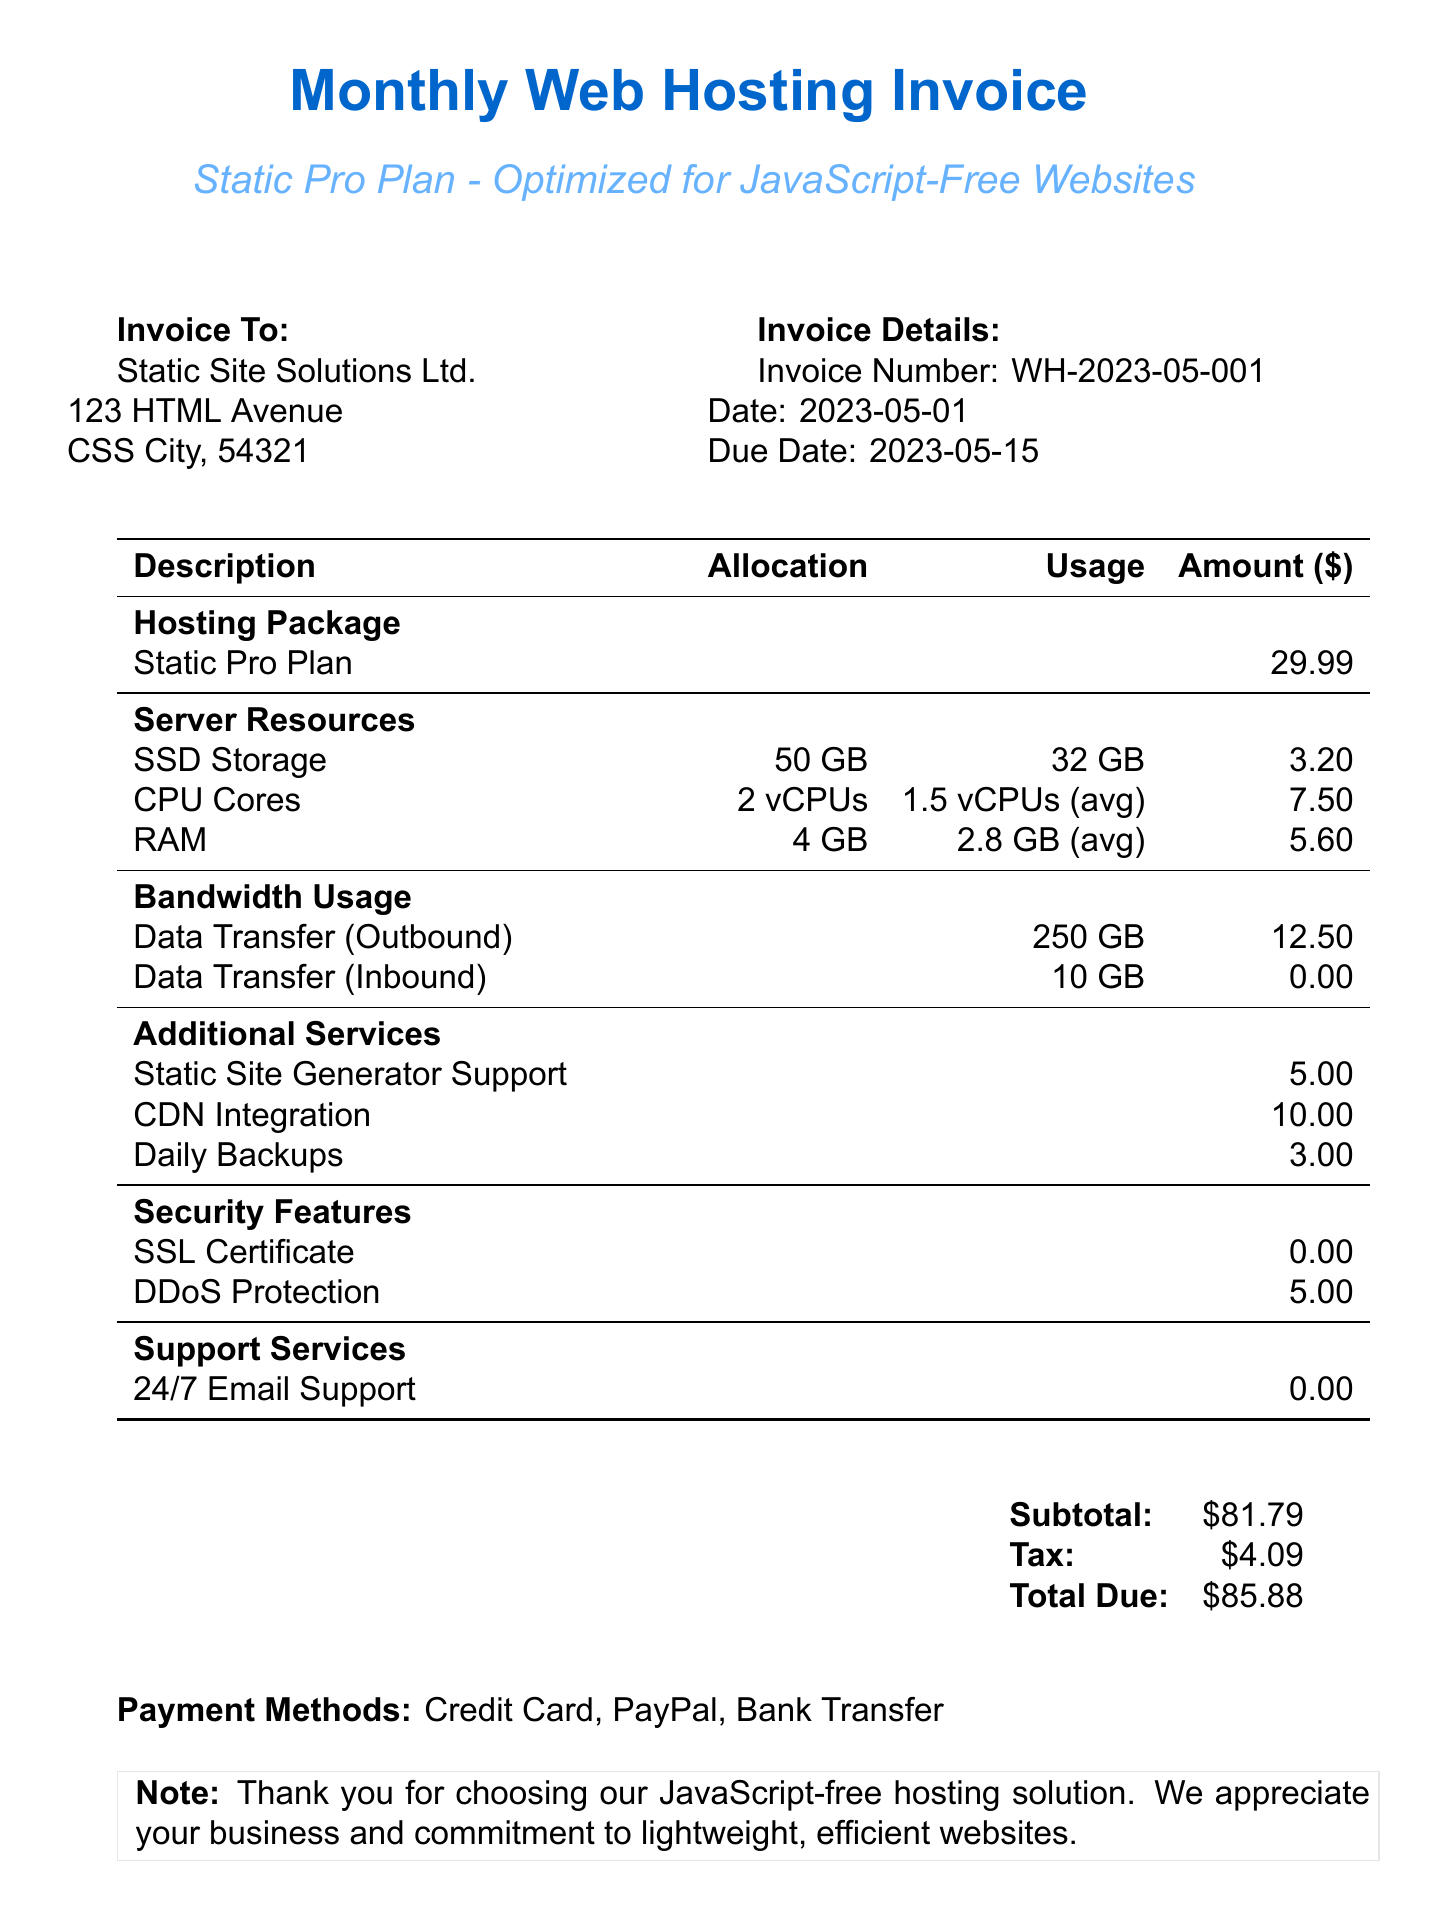What is the invoice number? The invoice number listed in the document is a specific identifier for this transaction, which is WH-2023-05-001.
Answer: WH-2023-05-001 What is the monthly fee for the hosting package? The monthly fee is specified within the hosting package details and is an important cost figure for the client to understand their monthly expenses.
Answer: 29.99 What is the total due amount? The total due amount is the final figure that the client needs to pay, including subtotal and tax, as provided in the invoice.
Answer: 85.88 How many CPU cores are allocated in the server resources? The allocation details highlight how many vCPUs (virtual Central Processing Units) are granted, crucial for understanding resource limits.
Answer: 2 vCPUs What is included in the additional services? By identifying the additional services, the client can see what extras are provided beyond the standard package, enhancing their hosting experience.
Answer: Static Site Generator Support, CDN Integration, Daily Backups How much is charged for DDoS Protection? This is a specific charge detailed under security features and gives insight into the costs associated with security measures for the website.
Answer: 5.00 When is the invoice due date? The due date is essential for the client to note in order to make timely payments and avoid late fees.
Answer: 2023-05-15 What is the tax amount on this invoice? The tax amount affects the total invoice amount and is important for budget considerations.
Answer: 4.09 What note is added to the invoice? The note provides additional context or appreciation from the hosting provider, which can enhance customer relations.
Answer: Thank you for choosing our JavaScript-free hosting solution. We appreciate your business and commitment to lightweight, efficient websites 